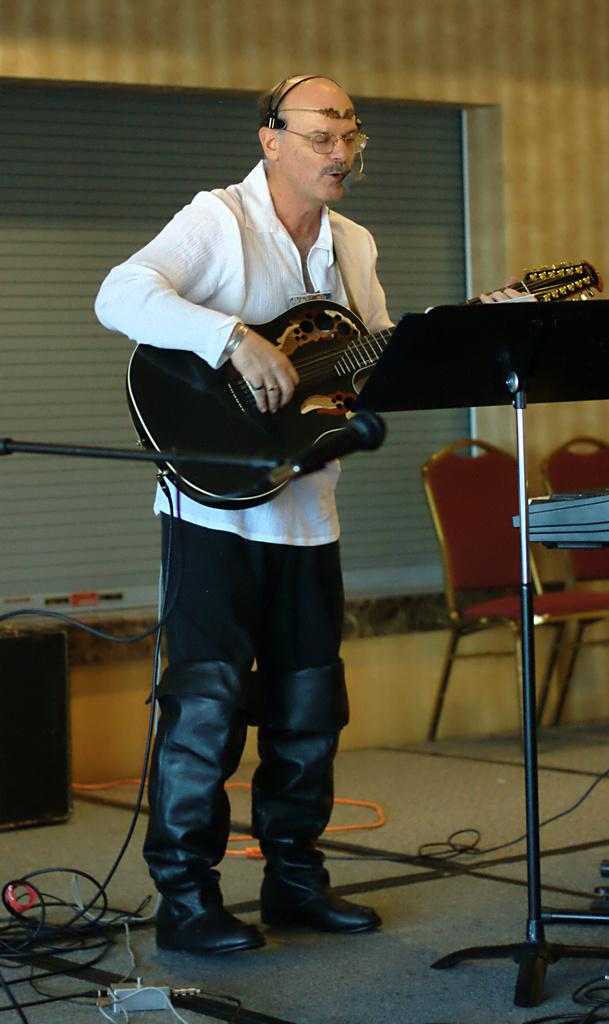What is the main subject of the image? The main subject of the image is a man. What is the man doing in the image? The man is standing in the image. What object is the man holding in the image? The man is holding a guitar in his hand. What type of silk material is draped over the man's shoulders in the image? There is no silk material draped over the man's shoulders in the image. What unit of measurement is used to determine the size of the guitar in the image? The provided facts do not mention any unit of measurement for the guitar's size. 